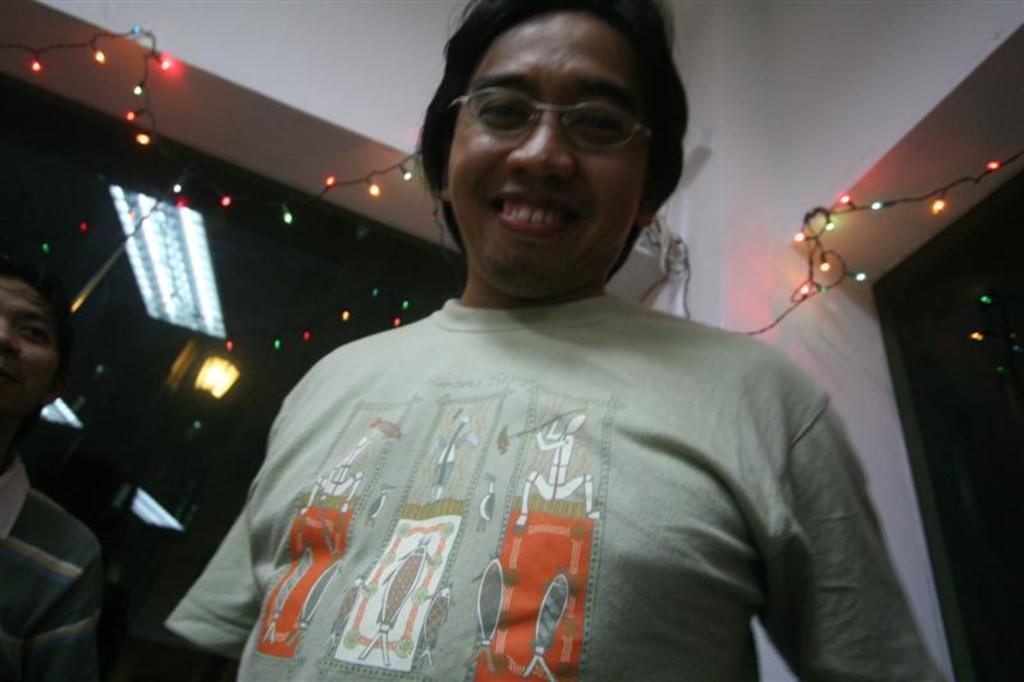Can you describe this image briefly? In this picture we can observe a person wearing a T shirt and spectacles. He is smiling. On the left side there is another person. In the background we can observe some lights and a wall. There is a glass. 